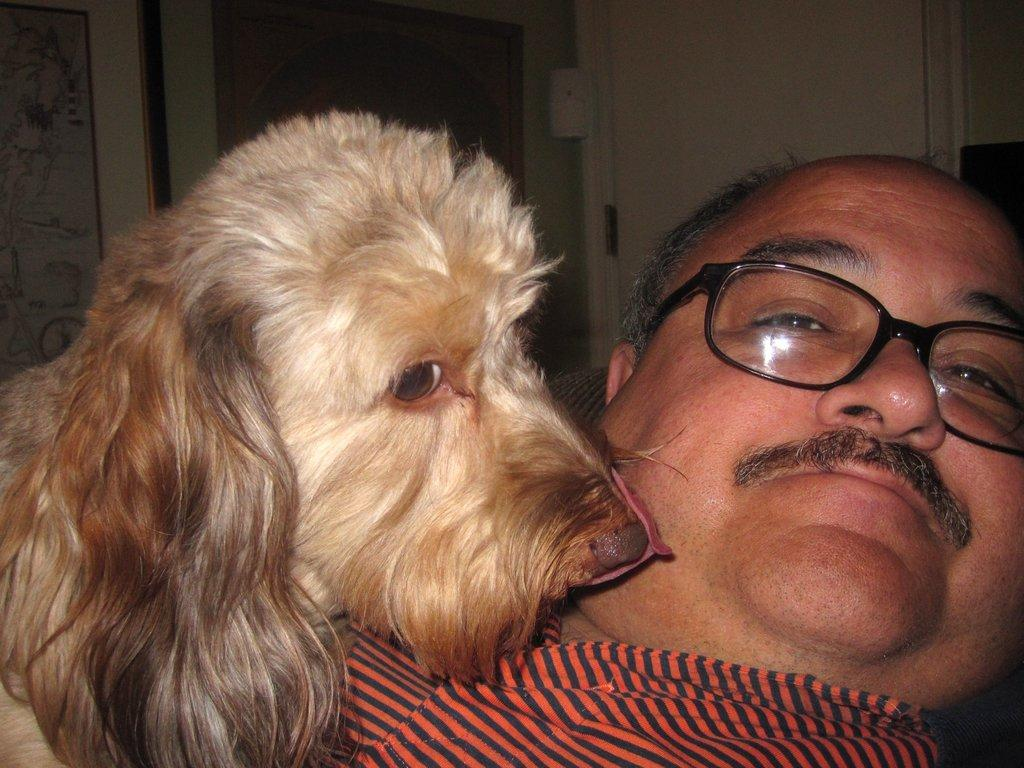What is located on the right side of the image? There is a man on the right side of the image. What is the man doing in the image? The man is smiling and looking at a picture. What type of animal is beside the man? There is an animal beside the man, but the specific type of animal is not mentioned in the facts. What can be seen in the background of the image? There is a wall and a door in the background of the image. What type of bottle is the man holding in the image? There is no mention of a bottle in the image, so it cannot be determined if the man is holding one. Can you tell me how many kitties are visible in the image? There is no mention of a kitty or any other type of animal besides the one mentioned in the facts, so it cannot be determined how many kitties are visible in the image. 